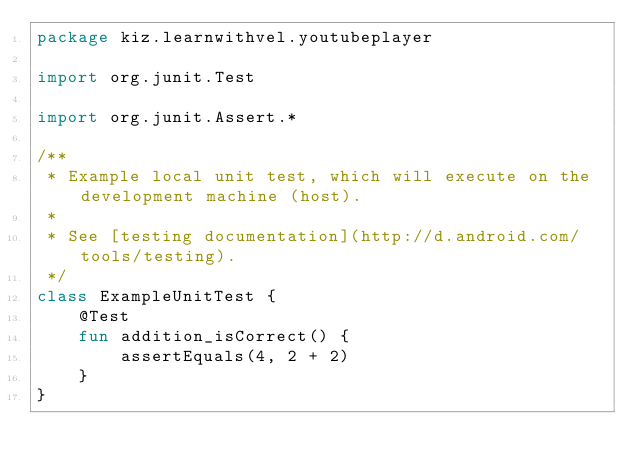Convert code to text. <code><loc_0><loc_0><loc_500><loc_500><_Kotlin_>package kiz.learnwithvel.youtubeplayer

import org.junit.Test

import org.junit.Assert.*

/**
 * Example local unit test, which will execute on the development machine (host).
 *
 * See [testing documentation](http://d.android.com/tools/testing).
 */
class ExampleUnitTest {
    @Test
    fun addition_isCorrect() {
        assertEquals(4, 2 + 2)
    }
}</code> 